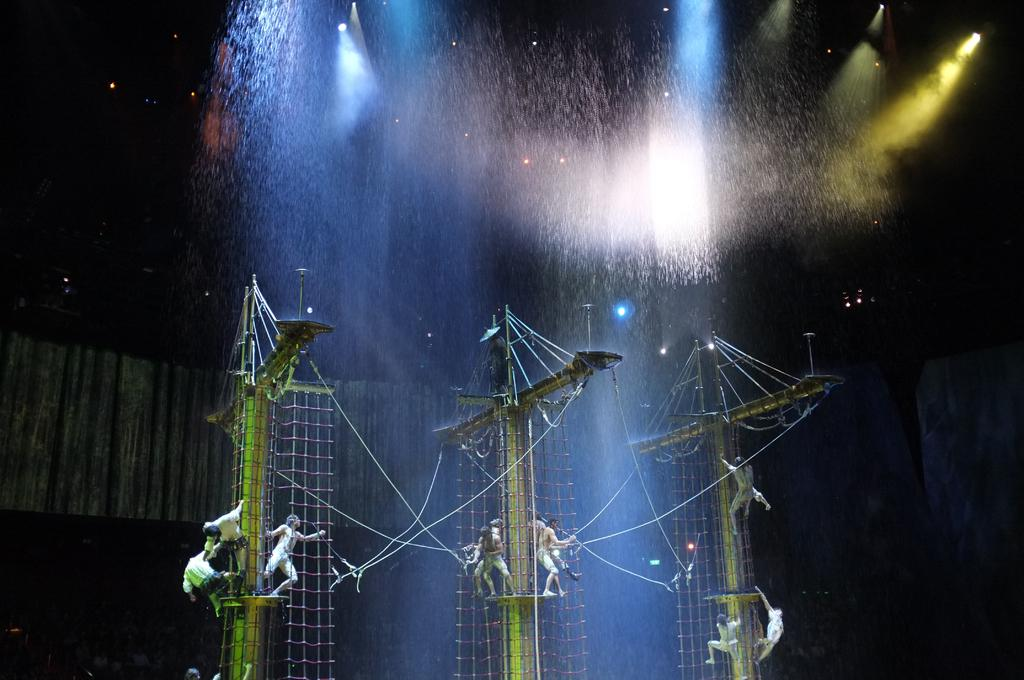What are the persons in the image doing? The persons in the image are standing on poles. What is attached to the poles? The poles have nets on them. What can be seen above the poles? There are lights above the poles. What type of event might be taking place in the image? The scene appears to be a circus. What type of eggs can be seen being cracked by the secretary in the image? There is no secretary or eggs present in the image. What action are the persons on the poles performing in the image? The persons on the poles are standing, not performing any specific action. 